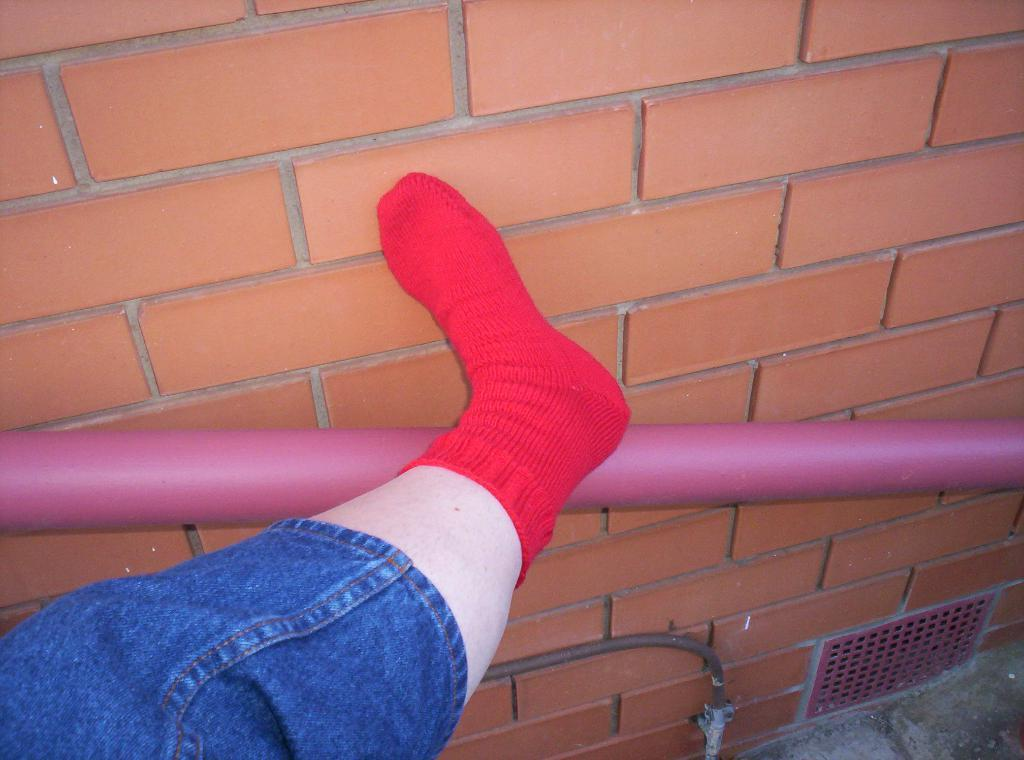What part of the human body is visible in the image? There is a human leg in the image. What color are the socks on the leg? The leg is wearing red socks. What can be seen in the background of the image? There is a wall in the background of the image. How many sisters are playing in the harbor near the school in the image? There are no sisters, harbor, or school present in the image; it only features a human leg wearing red socks with a wall in the background. 